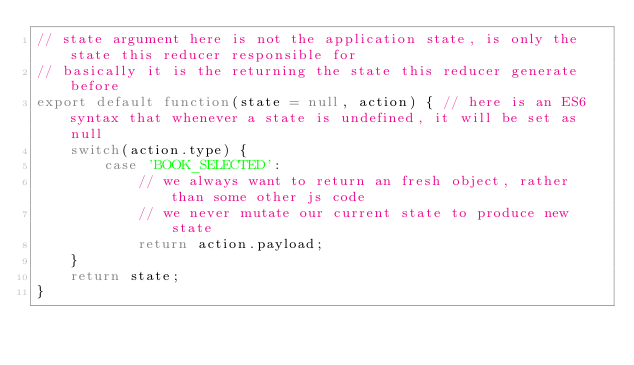Convert code to text. <code><loc_0><loc_0><loc_500><loc_500><_JavaScript_>// state argument here is not the application state, is only the state this reducer responsible for
// basically it is the returning the state this reducer generate before
export default function(state = null, action) { // here is an ES6 syntax that whenever a state is undefined, it will be set as null
    switch(action.type) {
        case 'BOOK_SELECTED':
            // we always want to return an fresh object, rather than some other js code
            // we never mutate our current state to produce new state
            return action.payload;
    }
    return state;
}</code> 